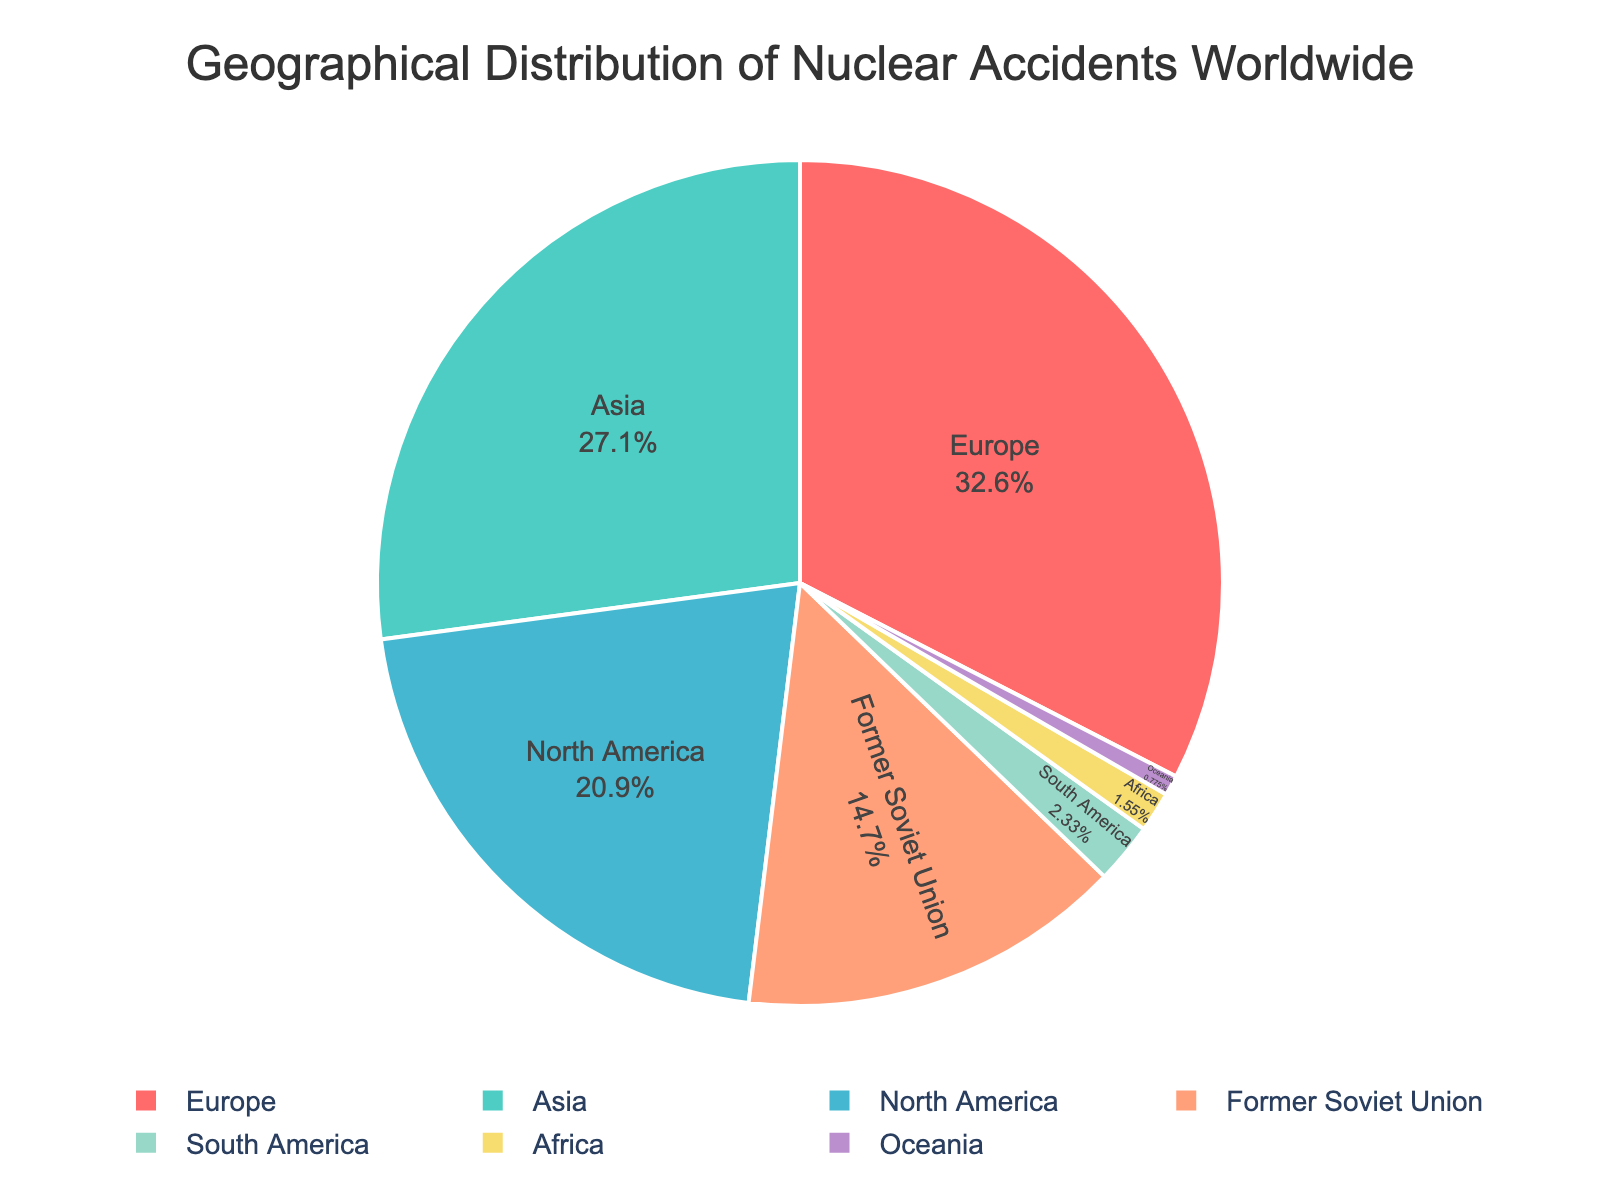What's the region with the highest number of nuclear accidents? Upon observing the pie chart, one can see that the region labeled "Europe" occupies the largest segment of the pie, indicating the highest number of nuclear accidents.
Answer: Europe Which regions have the lowest number of nuclear accidents? By looking at the smallest slices in the pie chart, we can identify the regions with the least nuclear accidents. These regions are "Oceania" and "Africa," each with minor slices.
Answer: Oceania and Africa How does the number of accidents in North America compare with those in Asia? By comparing the sizes of the slices represented by "North America" and "Asia," it is visible that the "Asia" slice is larger, implying more accidents. North America has 27, while Asia has 35 accidents.
Answer: Asia has more accidents than North America What percentage of nuclear accidents happened in Europe? The pie chart is labeled with percentages. Observing the "Europe" segment reveals its percentage share of the total accidents.
Answer: 34.71% How many more accidents occurred in Europe compared to the Former Soviet Union? From the data, Europe has 42 accidents and the Former Soviet Union has 19. The difference is calculated by subtracting 19 from 42.
Answer: 23 What percentage of accidents occurred in both South America and Africa combined? The pie chart shows the percentages for South America and Africa individually. Adding these two percentages from the chart gives the combined percentage.
Answer: 3.31% + 2.25% = 5.56% Which region's slice color is red, and how many accidents are reported for that region? Observing the colors associated with each region's slice, the red slice corresponds to a region. The "North America" region is depicted with a red slice on the pie chart, and it has 27 accidents.
Answer: North America, 27 Is there a region with a number of accidents equal to or less than the number of accidents in South America? From the chart, South America has 3 accidents. Comparing this number with other regions, "Africa" with 2 and "Oceania" with 1 both have less, or equal accidents to South America.
Answer: Africa, Oceania 